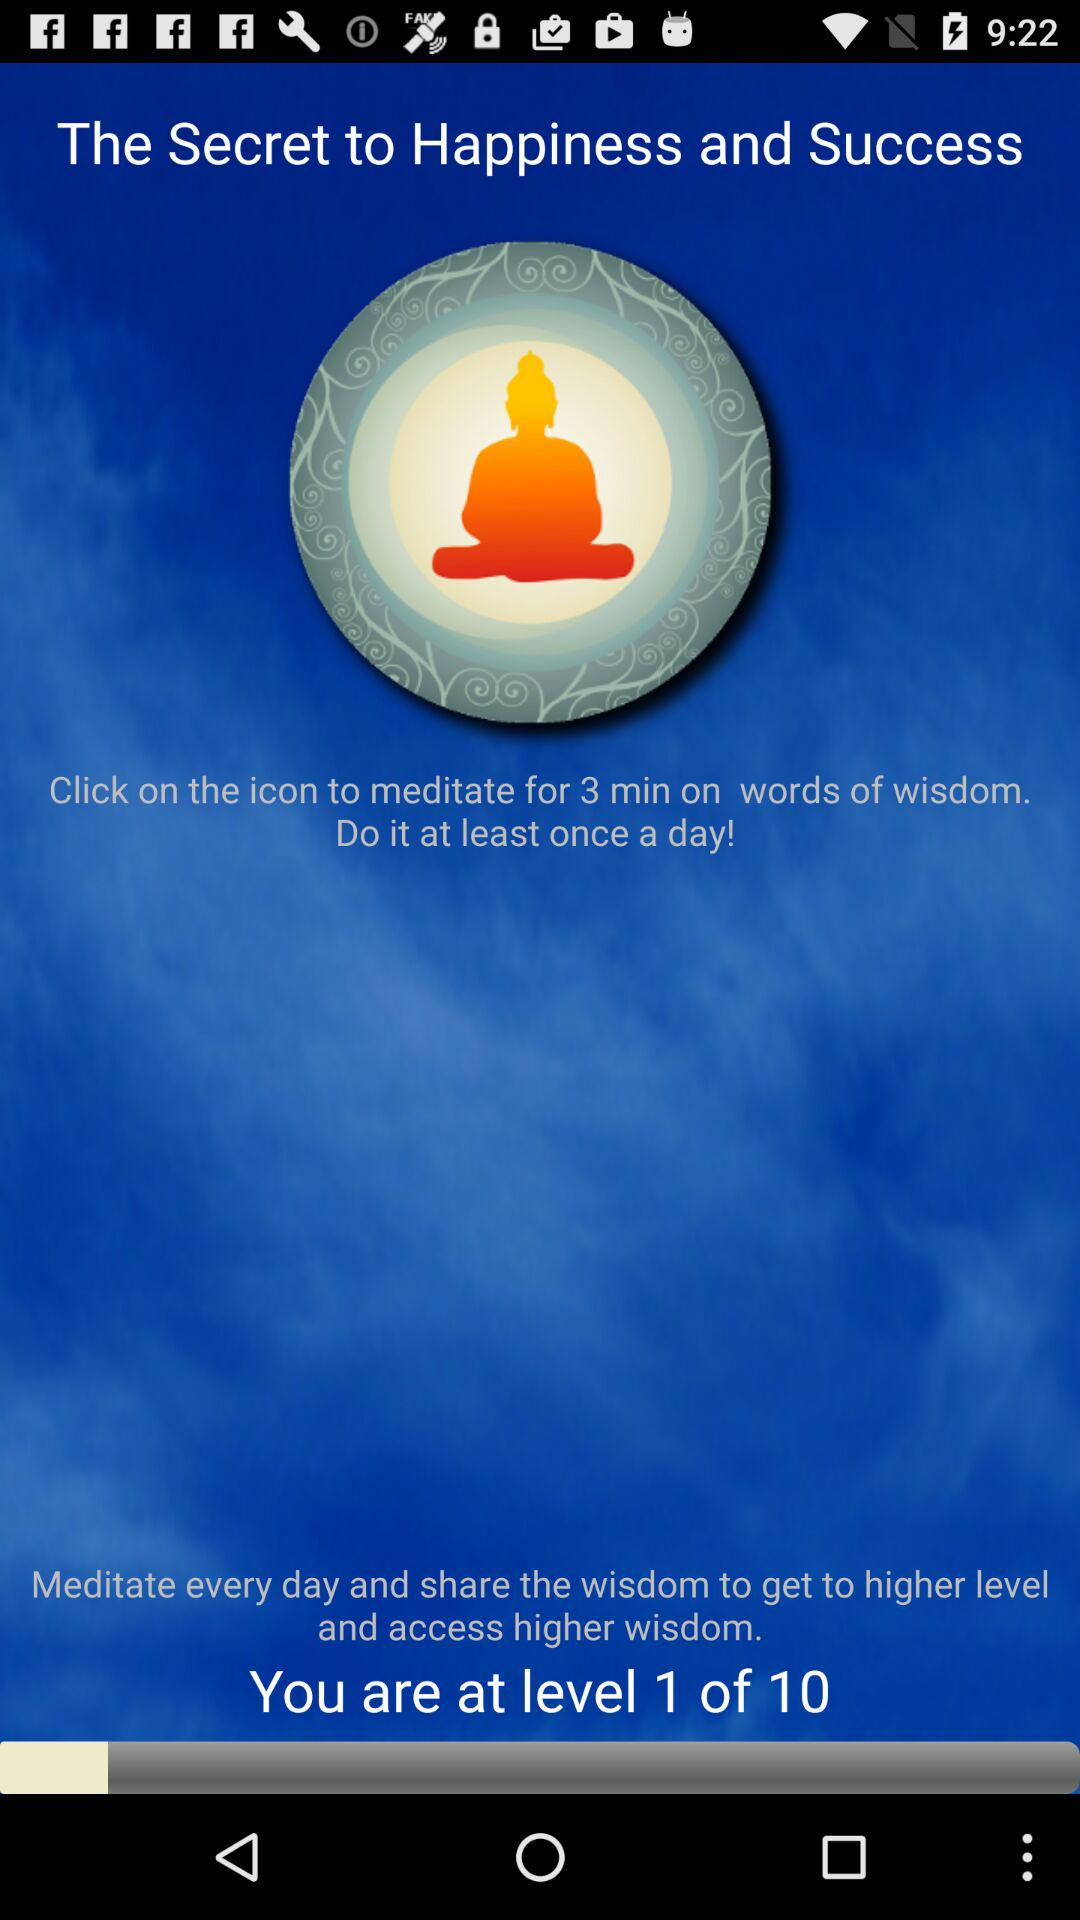How much time for meditation? The time is 3 minutes. 